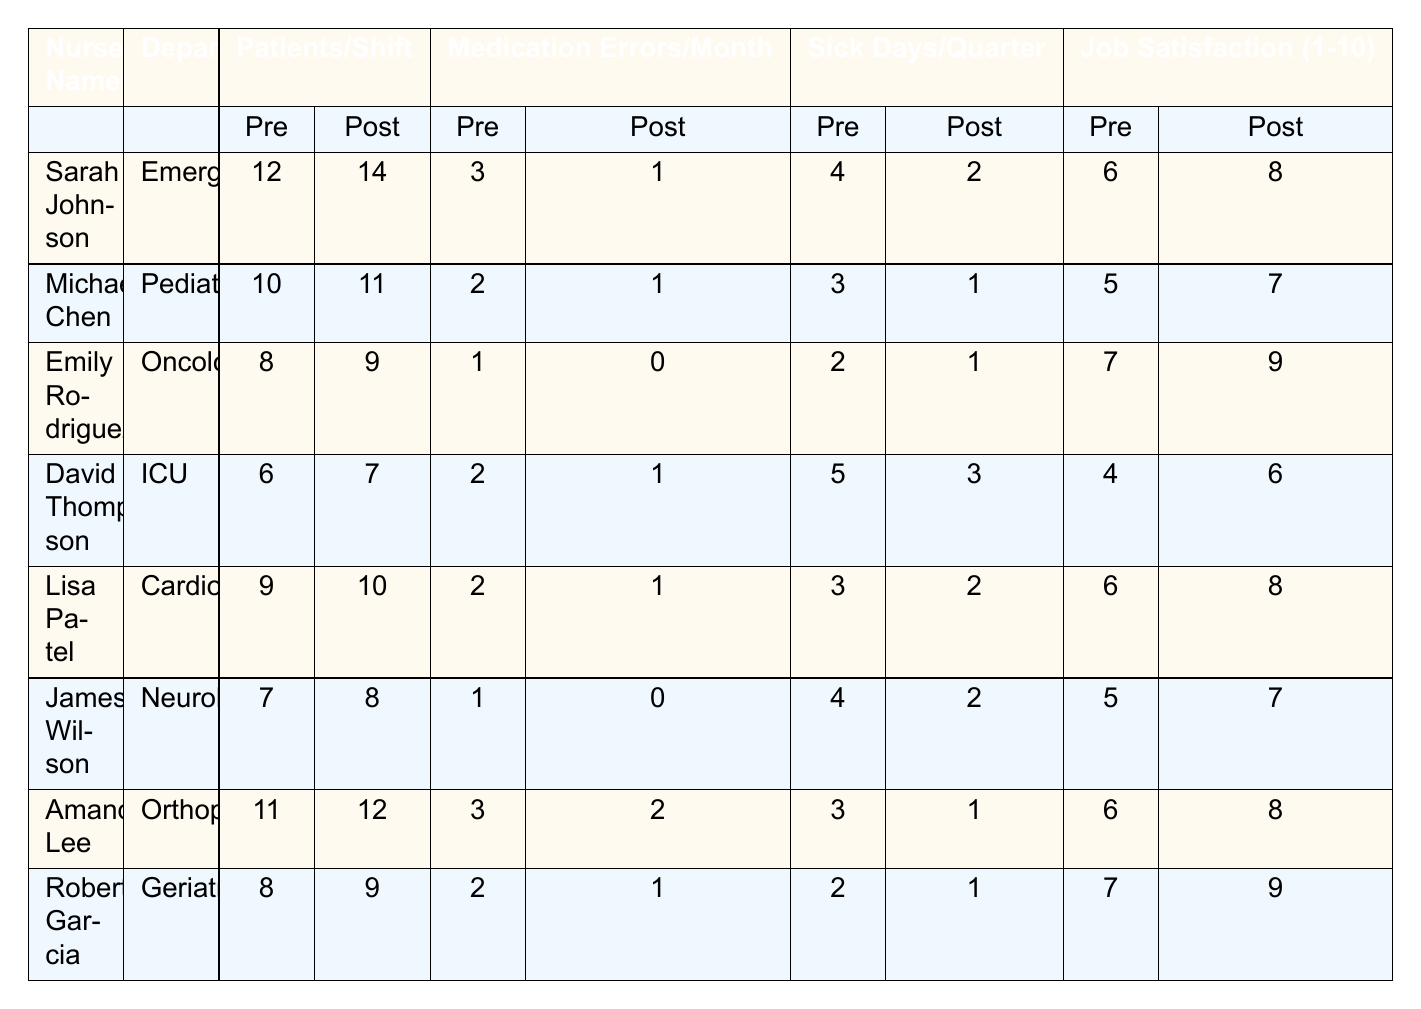What was the highest number of patients seen per shift after self-care implementation? Looking at the 'Post-Self-Care Patients/Shift' column, Sarah Johnson has the highest number of patients seen per shift at 14.
Answer: 14 How many nurses had a decrease in medication errors after implementing self-care routines? By examining the 'Pre-Self-Care Medication Errors/Month' and 'Post-Self-Care Medication Errors/Month' columns, five nurses (Sarah Johnson, Michael Chen, Emily Rodriguez, David Thompson, and Amanda Lee) show a decrease in medication errors.
Answer: 5 What was the change in sick days per quarter for David Thompson? David Thompson had 5 sick days per quarter before self-care and 3 after self-care. The change is 5 - 3 = 2 fewer sick days after implementation.
Answer: 2 Which department saw the highest improvement in job satisfaction? By comparing the 'Pre-Self-Care Job Satisfaction' and 'Post-Self-Care Job Satisfaction' columns, Emily Rodriguez improved from 7 to 9, which is an increase of 2 points, the highest improvement among all nurses.
Answer: 2 points Is there a nurse who did not experience any medication errors after implementing self-care? According to the 'Post-Self-Care Medication Errors/Month' column, Emily Rodriguez and James Wilson both had 0 medication errors after self-care implementation.
Answer: Yes What is the average number of patients seen per shift before self-care initiatives? The total number of patients seen before self-care by all nurses is 12 + 10 + 8 + 6 + 9 + 7 + 11 + 8 = 81. There are 8 nurses, so the average is 81 / 8 = 10.125.
Answer: 10.125 Did most nurses report an increase in job satisfaction after implementing self-care strategies? By comparing the 'Pre-Self-Care Job Satisfaction' and 'Post-Self-Care Job Satisfaction', all but one nurse (David Thompson, who improved from 4 to 6) reported an increase in job satisfaction.
Answer: Yes What overall trend is observed in the medication errors before and after self-care implementation? The table shows that the majority of nurses experienced a decrease in medication errors after self-care implementation, indicating an overall positive trend.
Answer: Decrease in errors overall Who had the lowest number of patients per shift after the implementation? Looking at the 'Post-Self-Care Patients/Shift' column, David Thompson has the lowest number of patients seen per shift after implementing self-care at 7.
Answer: 7 Calculate the total change in sick days among all nurses after self-care. The total sick days before self-care is 4 + 3 + 2 + 5 + 3 + 4 + 3 + 2 = 26, and after self-care is 2 + 1 + 1 + 3 + 2 + 2 + 1 + 1 = 13. The total change is 26 - 13 = 13 fewer sick days.
Answer: 13 fewer sick days 